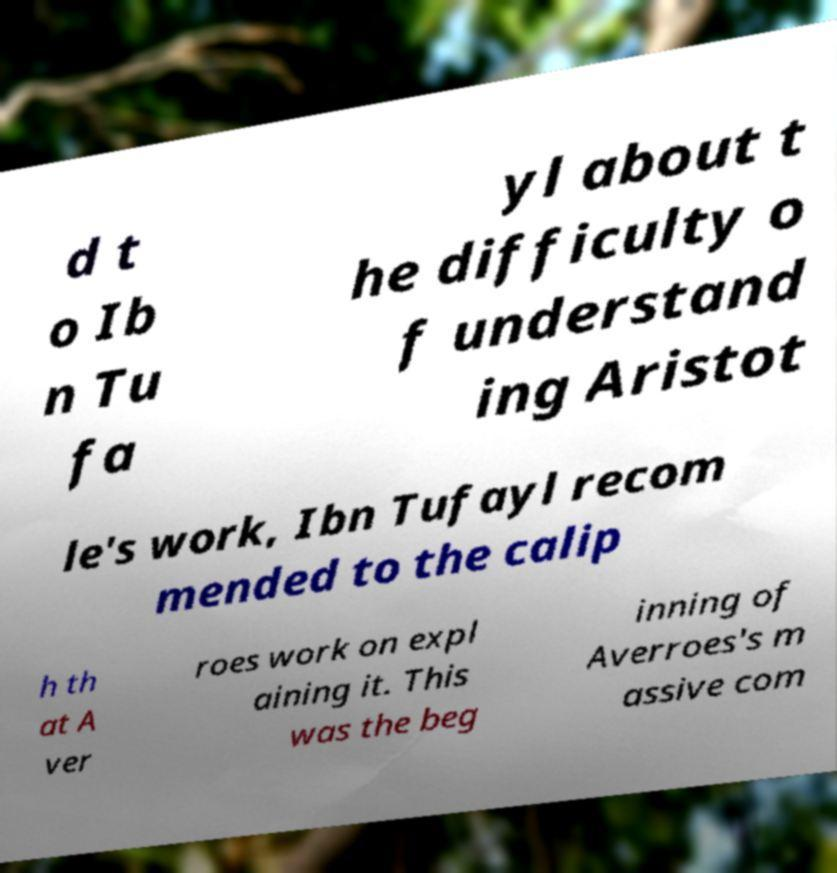Please read and relay the text visible in this image. What does it say? d t o Ib n Tu fa yl about t he difficulty o f understand ing Aristot le's work, Ibn Tufayl recom mended to the calip h th at A ver roes work on expl aining it. This was the beg inning of Averroes's m assive com 